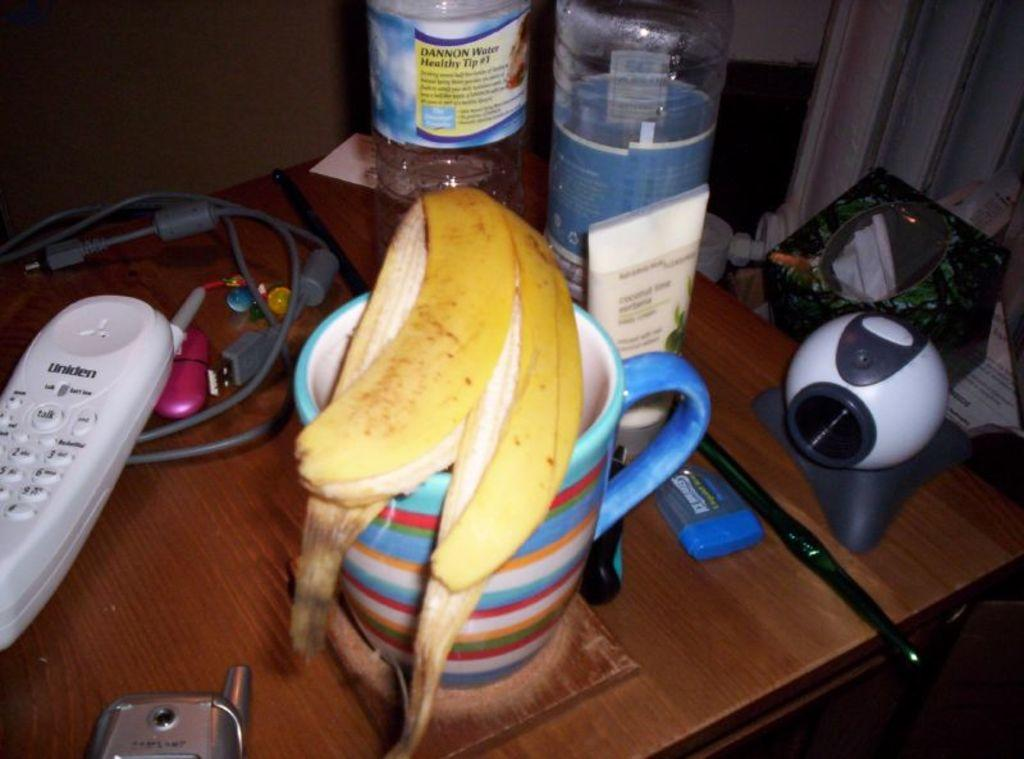<image>
Describe the image concisely. a uniden phone is sitting on the desk near the coffee cup 